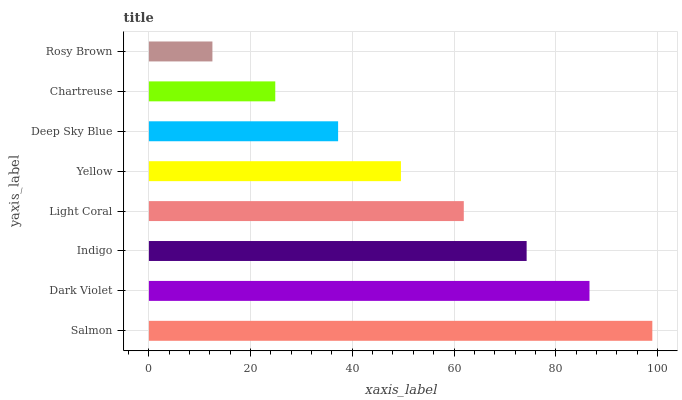Is Rosy Brown the minimum?
Answer yes or no. Yes. Is Salmon the maximum?
Answer yes or no. Yes. Is Dark Violet the minimum?
Answer yes or no. No. Is Dark Violet the maximum?
Answer yes or no. No. Is Salmon greater than Dark Violet?
Answer yes or no. Yes. Is Dark Violet less than Salmon?
Answer yes or no. Yes. Is Dark Violet greater than Salmon?
Answer yes or no. No. Is Salmon less than Dark Violet?
Answer yes or no. No. Is Light Coral the high median?
Answer yes or no. Yes. Is Yellow the low median?
Answer yes or no. Yes. Is Yellow the high median?
Answer yes or no. No. Is Chartreuse the low median?
Answer yes or no. No. 